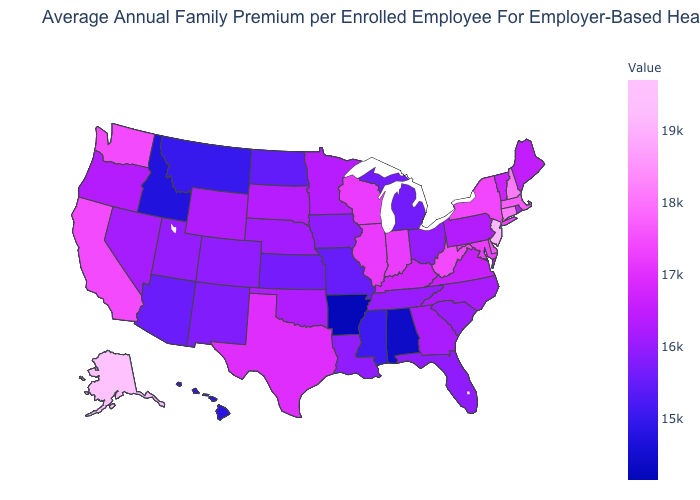Among the states that border New Hampshire , which have the lowest value?
Write a very short answer. Maine. Does Florida have a lower value than California?
Short answer required. Yes. Does New Jersey have the highest value in the Northeast?
Concise answer only. Yes. Does Pennsylvania have the lowest value in the Northeast?
Write a very short answer. Yes. Which states have the lowest value in the South?
Quick response, please. Arkansas. Does the map have missing data?
Short answer required. No. 